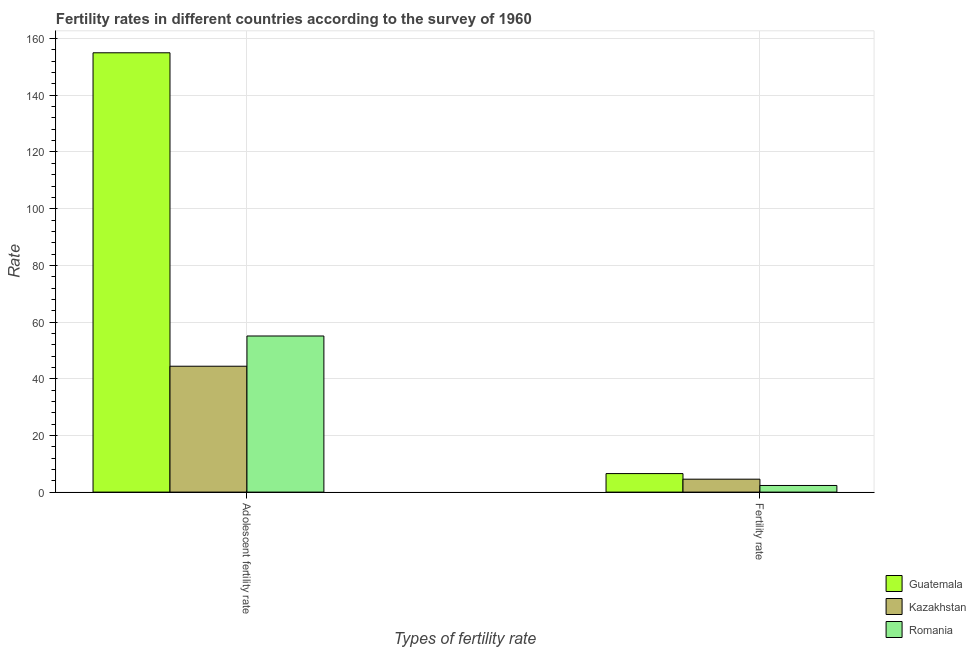Are the number of bars per tick equal to the number of legend labels?
Ensure brevity in your answer.  Yes. How many bars are there on the 2nd tick from the left?
Ensure brevity in your answer.  3. What is the label of the 2nd group of bars from the left?
Provide a succinct answer. Fertility rate. What is the fertility rate in Kazakhstan?
Provide a succinct answer. 4.56. Across all countries, what is the maximum adolescent fertility rate?
Give a very brief answer. 155. Across all countries, what is the minimum fertility rate?
Ensure brevity in your answer.  2.34. In which country was the fertility rate maximum?
Your answer should be compact. Guatemala. In which country was the fertility rate minimum?
Your response must be concise. Romania. What is the total fertility rate in the graph?
Provide a short and direct response. 13.44. What is the difference between the adolescent fertility rate in Kazakhstan and that in Guatemala?
Make the answer very short. -110.59. What is the difference between the adolescent fertility rate in Guatemala and the fertility rate in Kazakhstan?
Provide a short and direct response. 150.44. What is the average fertility rate per country?
Keep it short and to the point. 4.48. What is the difference between the adolescent fertility rate and fertility rate in Kazakhstan?
Your answer should be compact. 39.85. In how many countries, is the adolescent fertility rate greater than 84 ?
Your answer should be compact. 1. What is the ratio of the fertility rate in Romania to that in Kazakhstan?
Offer a terse response. 0.51. What does the 1st bar from the left in Adolescent fertility rate represents?
Your response must be concise. Guatemala. What does the 2nd bar from the right in Adolescent fertility rate represents?
Offer a terse response. Kazakhstan. How many countries are there in the graph?
Offer a terse response. 3. What is the difference between two consecutive major ticks on the Y-axis?
Your answer should be compact. 20. Are the values on the major ticks of Y-axis written in scientific E-notation?
Make the answer very short. No. Does the graph contain any zero values?
Your response must be concise. No. How many legend labels are there?
Make the answer very short. 3. How are the legend labels stacked?
Offer a very short reply. Vertical. What is the title of the graph?
Keep it short and to the point. Fertility rates in different countries according to the survey of 1960. What is the label or title of the X-axis?
Ensure brevity in your answer.  Types of fertility rate. What is the label or title of the Y-axis?
Ensure brevity in your answer.  Rate. What is the Rate of Guatemala in Adolescent fertility rate?
Make the answer very short. 155. What is the Rate in Kazakhstan in Adolescent fertility rate?
Make the answer very short. 44.42. What is the Rate of Romania in Adolescent fertility rate?
Your response must be concise. 55.08. What is the Rate in Guatemala in Fertility rate?
Make the answer very short. 6.53. What is the Rate in Kazakhstan in Fertility rate?
Give a very brief answer. 4.56. What is the Rate in Romania in Fertility rate?
Your answer should be very brief. 2.34. Across all Types of fertility rate, what is the maximum Rate in Guatemala?
Your answer should be compact. 155. Across all Types of fertility rate, what is the maximum Rate in Kazakhstan?
Your answer should be compact. 44.42. Across all Types of fertility rate, what is the maximum Rate of Romania?
Provide a succinct answer. 55.08. Across all Types of fertility rate, what is the minimum Rate in Guatemala?
Ensure brevity in your answer.  6.53. Across all Types of fertility rate, what is the minimum Rate in Kazakhstan?
Offer a very short reply. 4.56. Across all Types of fertility rate, what is the minimum Rate in Romania?
Make the answer very short. 2.34. What is the total Rate in Guatemala in the graph?
Make the answer very short. 161.54. What is the total Rate in Kazakhstan in the graph?
Offer a very short reply. 48.98. What is the total Rate of Romania in the graph?
Your answer should be very brief. 57.42. What is the difference between the Rate in Guatemala in Adolescent fertility rate and that in Fertility rate?
Your answer should be very brief. 148.47. What is the difference between the Rate in Kazakhstan in Adolescent fertility rate and that in Fertility rate?
Your response must be concise. 39.85. What is the difference between the Rate in Romania in Adolescent fertility rate and that in Fertility rate?
Offer a very short reply. 52.74. What is the difference between the Rate in Guatemala in Adolescent fertility rate and the Rate in Kazakhstan in Fertility rate?
Offer a terse response. 150.44. What is the difference between the Rate in Guatemala in Adolescent fertility rate and the Rate in Romania in Fertility rate?
Offer a very short reply. 152.66. What is the difference between the Rate of Kazakhstan in Adolescent fertility rate and the Rate of Romania in Fertility rate?
Provide a short and direct response. 42.08. What is the average Rate of Guatemala per Types of fertility rate?
Provide a short and direct response. 80.77. What is the average Rate of Kazakhstan per Types of fertility rate?
Keep it short and to the point. 24.49. What is the average Rate of Romania per Types of fertility rate?
Offer a very short reply. 28.71. What is the difference between the Rate in Guatemala and Rate in Kazakhstan in Adolescent fertility rate?
Provide a succinct answer. 110.59. What is the difference between the Rate of Guatemala and Rate of Romania in Adolescent fertility rate?
Offer a very short reply. 99.92. What is the difference between the Rate of Kazakhstan and Rate of Romania in Adolescent fertility rate?
Your answer should be very brief. -10.66. What is the difference between the Rate of Guatemala and Rate of Kazakhstan in Fertility rate?
Your response must be concise. 1.97. What is the difference between the Rate of Guatemala and Rate of Romania in Fertility rate?
Keep it short and to the point. 4.19. What is the difference between the Rate in Kazakhstan and Rate in Romania in Fertility rate?
Keep it short and to the point. 2.22. What is the ratio of the Rate of Guatemala in Adolescent fertility rate to that in Fertility rate?
Keep it short and to the point. 23.72. What is the ratio of the Rate of Kazakhstan in Adolescent fertility rate to that in Fertility rate?
Give a very brief answer. 9.73. What is the ratio of the Rate of Romania in Adolescent fertility rate to that in Fertility rate?
Give a very brief answer. 23.54. What is the difference between the highest and the second highest Rate of Guatemala?
Make the answer very short. 148.47. What is the difference between the highest and the second highest Rate of Kazakhstan?
Make the answer very short. 39.85. What is the difference between the highest and the second highest Rate in Romania?
Offer a terse response. 52.74. What is the difference between the highest and the lowest Rate of Guatemala?
Keep it short and to the point. 148.47. What is the difference between the highest and the lowest Rate in Kazakhstan?
Provide a short and direct response. 39.85. What is the difference between the highest and the lowest Rate in Romania?
Ensure brevity in your answer.  52.74. 